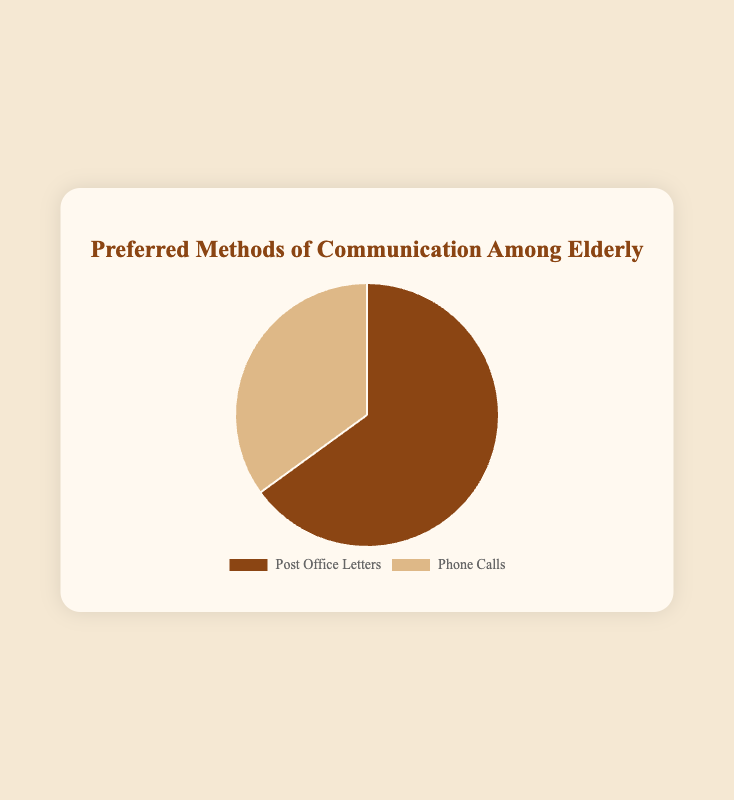Which communication method is preferred by the majority of elderly? The pie chart shows two communication methods: "Post Office Letters" and "Phone Calls" with percentages. The majority would be the larger percentage. "Post Office Letters" is at 65%, which is larger than "Phone Calls" at 35%.
Answer: Post Office Letters What percentage of elderly prefer phone calls as their communication method? The pie chart provides two data points: "Post Office Letters" at 65% and "Phone Calls" at 35%. The percentage for phone calls is directly labeled.
Answer: 35% How much larger is the percentage of elderly who prefer post office letters compared to those who prefer phone calls? The pie chart shows 65% for "Post Office Letters" and 35% for "Phone Calls". To find the difference, subtract the smaller percentage from the larger: 65% - 35% = 30%.
Answer: 30% If you combine both communication methods, what total percentage do you get? The pie chart has two segments: 65% for "Post Office Letters" and 35% for "Phone Calls". Adding these percentages gives the total: 65% + 35% = 100%.
Answer: 100% What method has the least preference among the elderly? The pie chart shows that "Phone Calls" has 35% whereas "Post Office Letters" has 65%. The smaller percentage indicates the least preference.
Answer: Phone Calls By what factor is the preference for post office letters greater than that for phone calls? Divide the percentage of "Post Office Letters" by the percentage of "Phone Calls" to get the factor: 65% / 35% = 1.857.
Answer: 1.857 What are the colors used to depict the different communication methods in the pie chart? The pie chart uses colors to visually distinguish between communication methods. "Post Office Letters" is depicted in brown, and "Phone Calls" is depicted in light brown.
Answer: Brown and light brown What is the ratio of elderly people who prefer post office letters to those who prefer phone calls? The pie chart shows 65% for "Post Office Letters" and 35% for "Phone Calls". To find the ratio, express these as a fraction and simplify: 65/35 = 13/7.
Answer: 13:7 Which method is more than twice as popular as the other? The pie chart shows "Post Office Letters" at 65% and "Phone Calls" at 35%. Since 65% is greater than twice 35% (which is 70%), it meets this condition.
Answer: Neither 